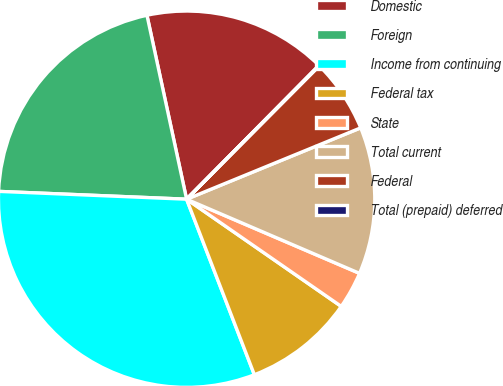<chart> <loc_0><loc_0><loc_500><loc_500><pie_chart><fcel>Domestic<fcel>Foreign<fcel>Income from continuing<fcel>Federal tax<fcel>State<fcel>Total current<fcel>Federal<fcel>Total (prepaid) deferred<nl><fcel>15.79%<fcel>20.96%<fcel>31.53%<fcel>9.49%<fcel>3.2%<fcel>12.64%<fcel>6.35%<fcel>0.05%<nl></chart> 